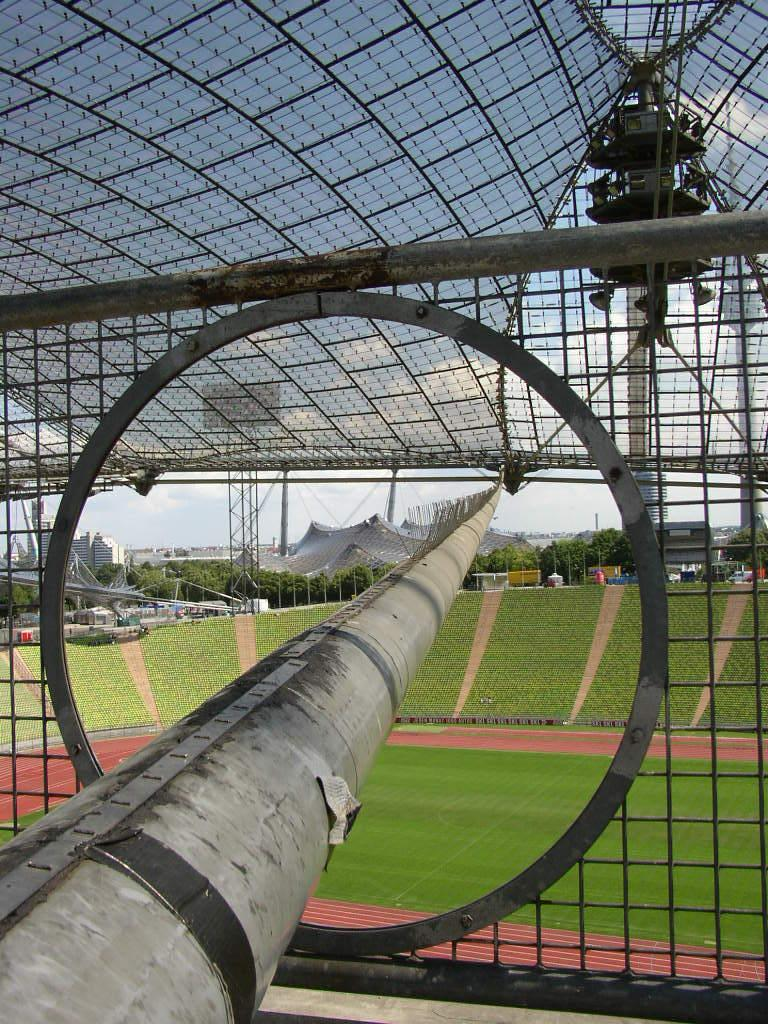What type of material is used to create the net in the image? The net in the image is made of iron. Where is the iron net located in the image? The iron net is in the middle of the image. What is visible beneath the iron net in the image? There is a ground visible in the image. What type of oil can be seen dripping from the iron net in the image? There is no oil present in the image, and the iron net is not dripping anything. 